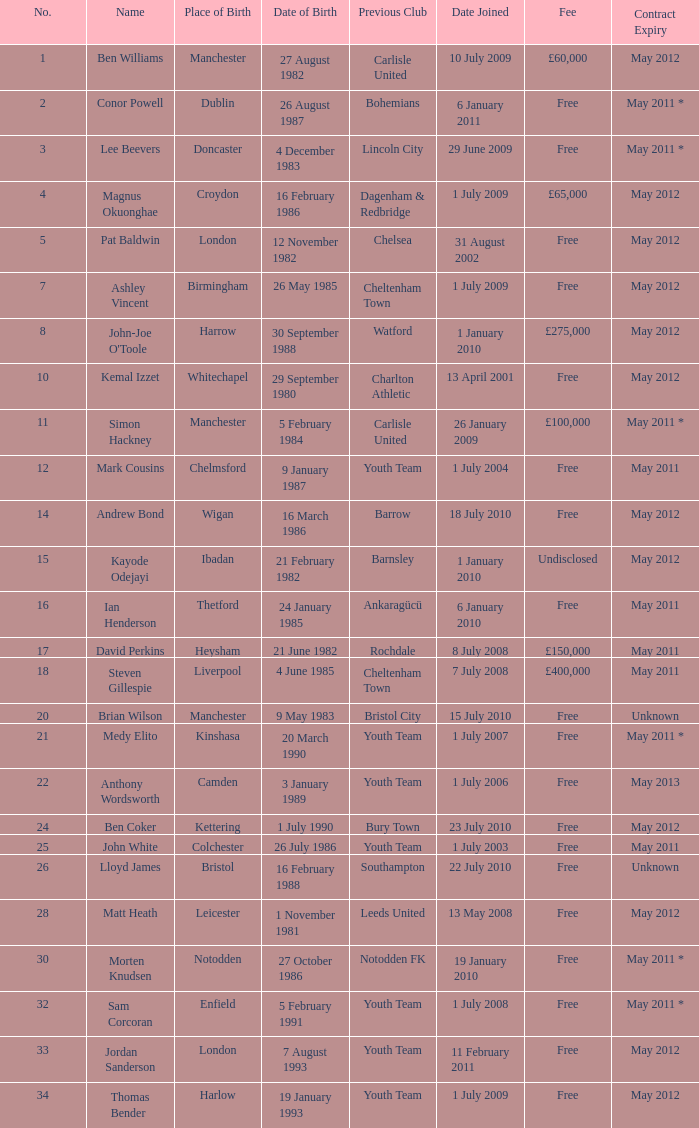For the no. 7 what is the date of birth 26 May 1985. 